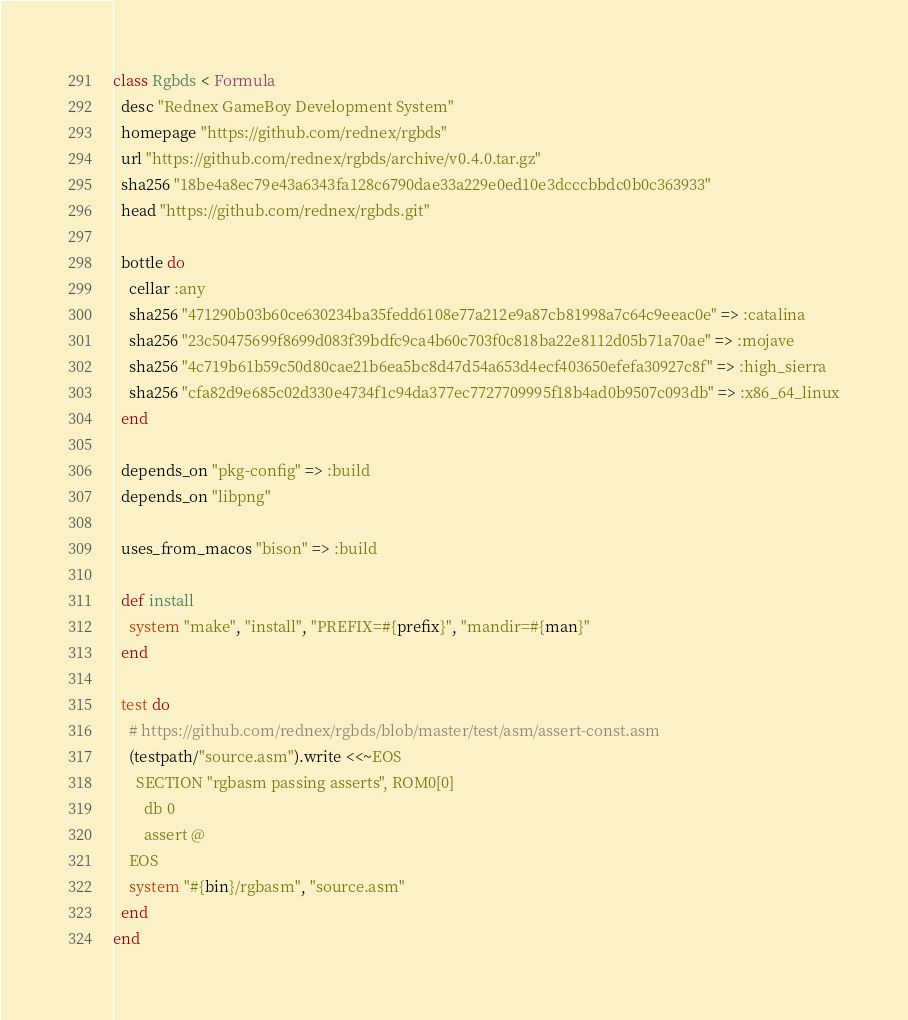Convert code to text. <code><loc_0><loc_0><loc_500><loc_500><_Ruby_>class Rgbds < Formula
  desc "Rednex GameBoy Development System"
  homepage "https://github.com/rednex/rgbds"
  url "https://github.com/rednex/rgbds/archive/v0.4.0.tar.gz"
  sha256 "18be4a8ec79e43a6343fa128c6790dae33a229e0ed10e3dcccbbdc0b0c363933"
  head "https://github.com/rednex/rgbds.git"

  bottle do
    cellar :any
    sha256 "471290b03b60ce630234ba35fedd6108e77a212e9a87cb81998a7c64c9eeac0e" => :catalina
    sha256 "23c50475699f8699d083f39bdfc9ca4b60c703f0c818ba22e8112d05b71a70ae" => :mojave
    sha256 "4c719b61b59c50d80cae21b6ea5bc8d47d54a653d4ecf403650efefa30927c8f" => :high_sierra
    sha256 "cfa82d9e685c02d330e4734f1c94da377ec7727709995f18b4ad0b9507c093db" => :x86_64_linux
  end

  depends_on "pkg-config" => :build
  depends_on "libpng"

  uses_from_macos "bison" => :build

  def install
    system "make", "install", "PREFIX=#{prefix}", "mandir=#{man}"
  end

  test do
    # https://github.com/rednex/rgbds/blob/master/test/asm/assert-const.asm
    (testpath/"source.asm").write <<~EOS
      SECTION "rgbasm passing asserts", ROM0[0]
        db 0
        assert @
    EOS
    system "#{bin}/rgbasm", "source.asm"
  end
end
</code> 